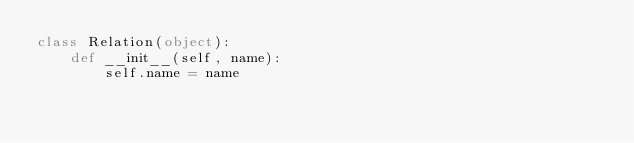<code> <loc_0><loc_0><loc_500><loc_500><_Python_>class Relation(object):
    def __init__(self, name):
        self.name = name

</code> 